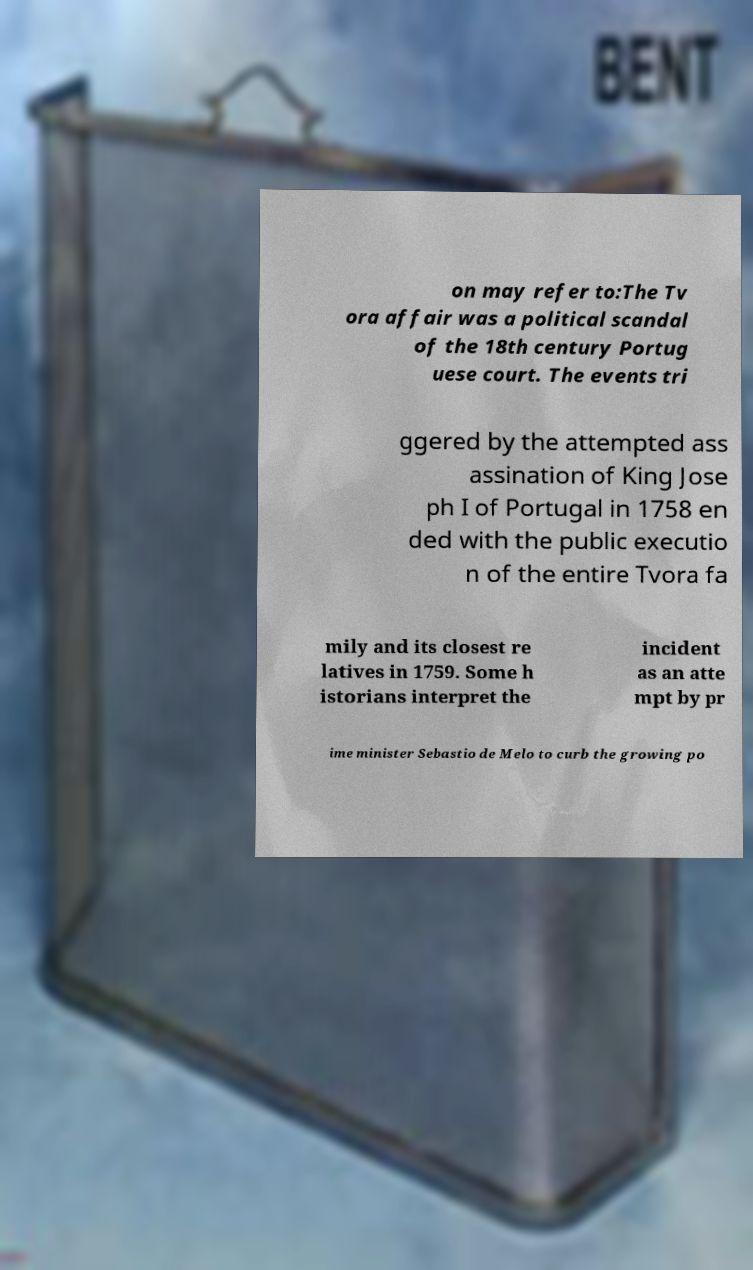For documentation purposes, I need the text within this image transcribed. Could you provide that? on may refer to:The Tv ora affair was a political scandal of the 18th century Portug uese court. The events tri ggered by the attempted ass assination of King Jose ph I of Portugal in 1758 en ded with the public executio n of the entire Tvora fa mily and its closest re latives in 1759. Some h istorians interpret the incident as an atte mpt by pr ime minister Sebastio de Melo to curb the growing po 